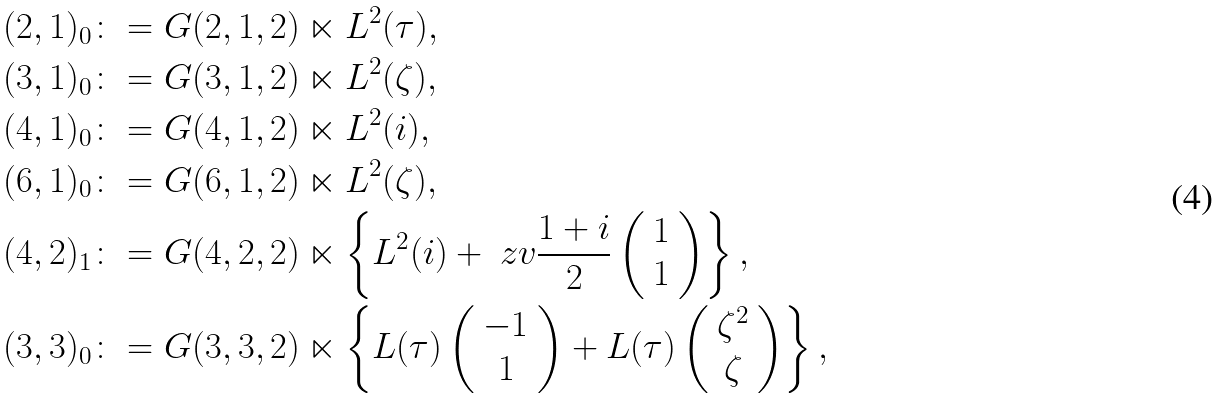Convert formula to latex. <formula><loc_0><loc_0><loc_500><loc_500>( 2 , 1 ) _ { 0 } & \colon = G ( 2 , 1 , 2 ) \ltimes L ^ { 2 } ( \tau ) , \\ ( 3 , 1 ) _ { 0 } & \colon = G ( 3 , 1 , 2 ) \ltimes L ^ { 2 } ( \zeta ) , \\ ( 4 , 1 ) _ { 0 } & \colon = G ( 4 , 1 , 2 ) \ltimes L ^ { 2 } ( i ) , \\ ( 6 , 1 ) _ { 0 } & \colon = G ( 6 , 1 , 2 ) \ltimes L ^ { 2 } ( \zeta ) , \\ ( 4 , 2 ) _ { 1 } & \colon = G ( 4 , 2 , 2 ) \ltimes \left \{ L ^ { 2 } ( i ) + \ z v \frac { 1 + i } { 2 } \left ( \begin{array} { c } 1 \\ 1 \end{array} \right ) \right \} , \\ ( 3 , 3 ) _ { 0 } & \colon = G ( 3 , 3 , 2 ) \ltimes \left \{ L ( \tau ) \left ( \begin{array} { c } - 1 \\ 1 \end{array} \right ) + L ( \tau ) \left ( \begin{array} { c } \zeta ^ { 2 } \\ \zeta \end{array} \right ) \right \} ,</formula> 